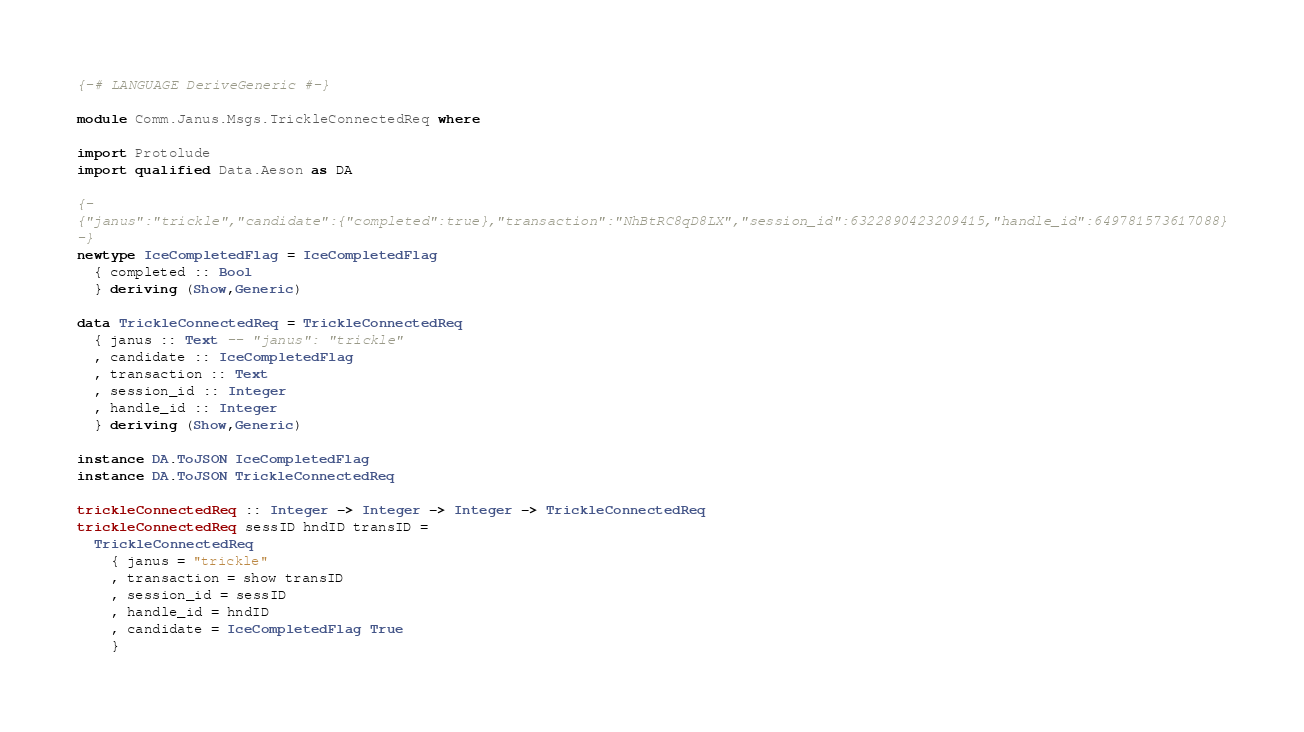<code> <loc_0><loc_0><loc_500><loc_500><_Haskell_>{-# LANGUAGE DeriveGeneric #-}

module Comm.Janus.Msgs.TrickleConnectedReq where

import Protolude
import qualified Data.Aeson as DA

{-
{"janus":"trickle","candidate":{"completed":true},"transaction":"NhBtRC8qD8LX","session_id":6322890423209415,"handle_id":649781573617088}
-}
newtype IceCompletedFlag = IceCompletedFlag
  { completed :: Bool
  } deriving (Show,Generic)

data TrickleConnectedReq = TrickleConnectedReq
  { janus :: Text -- "janus": "trickle"
  , candidate :: IceCompletedFlag
  , transaction :: Text
  , session_id :: Integer
  , handle_id :: Integer
  } deriving (Show,Generic)

instance DA.ToJSON IceCompletedFlag
instance DA.ToJSON TrickleConnectedReq

trickleConnectedReq :: Integer -> Integer -> Integer -> TrickleConnectedReq
trickleConnectedReq sessID hndID transID =
  TrickleConnectedReq
    { janus = "trickle"
    , transaction = show transID
    , session_id = sessID
    , handle_id = hndID
    , candidate = IceCompletedFlag True
    }
</code> 